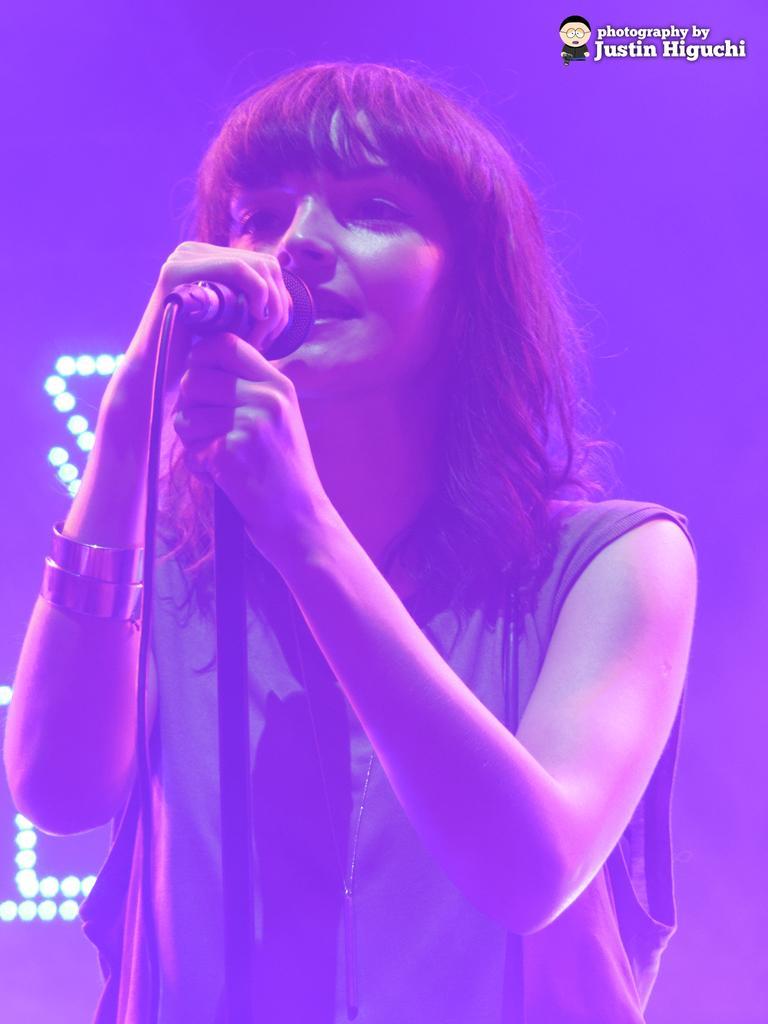How would you summarize this image in a sentence or two? In the a woman is standing and holding a microphone and singing. 